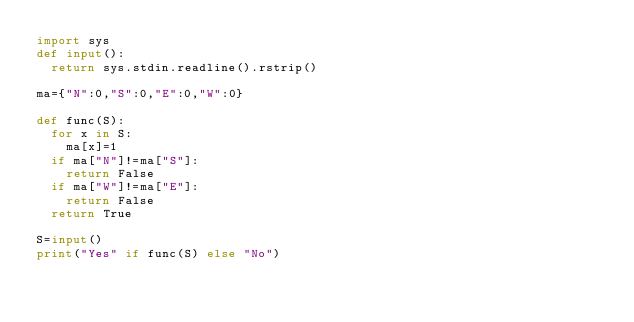Convert code to text. <code><loc_0><loc_0><loc_500><loc_500><_Python_>import sys
def input():
  return sys.stdin.readline().rstrip()

ma={"N":0,"S":0,"E":0,"W":0}

def func(S):
  for x in S:
    ma[x]=1
  if ma["N"]!=ma["S"]:
    return False
  if ma["W"]!=ma["E"]:
    return False
  return True

S=input()
print("Yes" if func(S) else "No")
</code> 